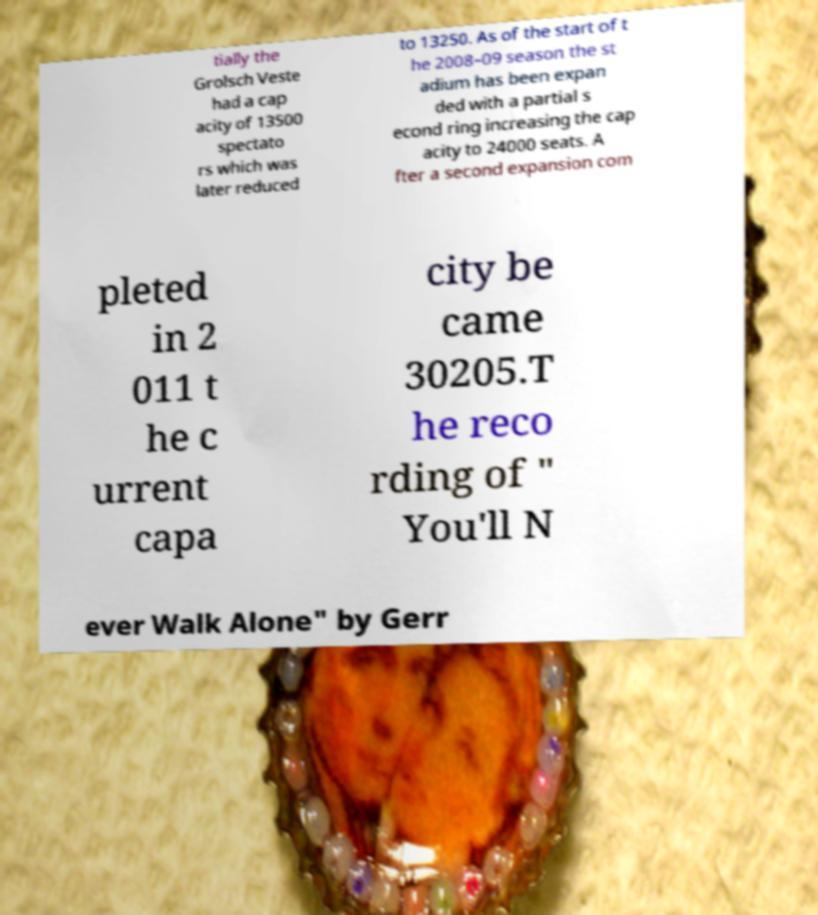There's text embedded in this image that I need extracted. Can you transcribe it verbatim? tially the Grolsch Veste had a cap acity of 13500 spectato rs which was later reduced to 13250. As of the start of t he 2008–09 season the st adium has been expan ded with a partial s econd ring increasing the cap acity to 24000 seats. A fter a second expansion com pleted in 2 011 t he c urrent capa city be came 30205.T he reco rding of " You'll N ever Walk Alone" by Gerr 